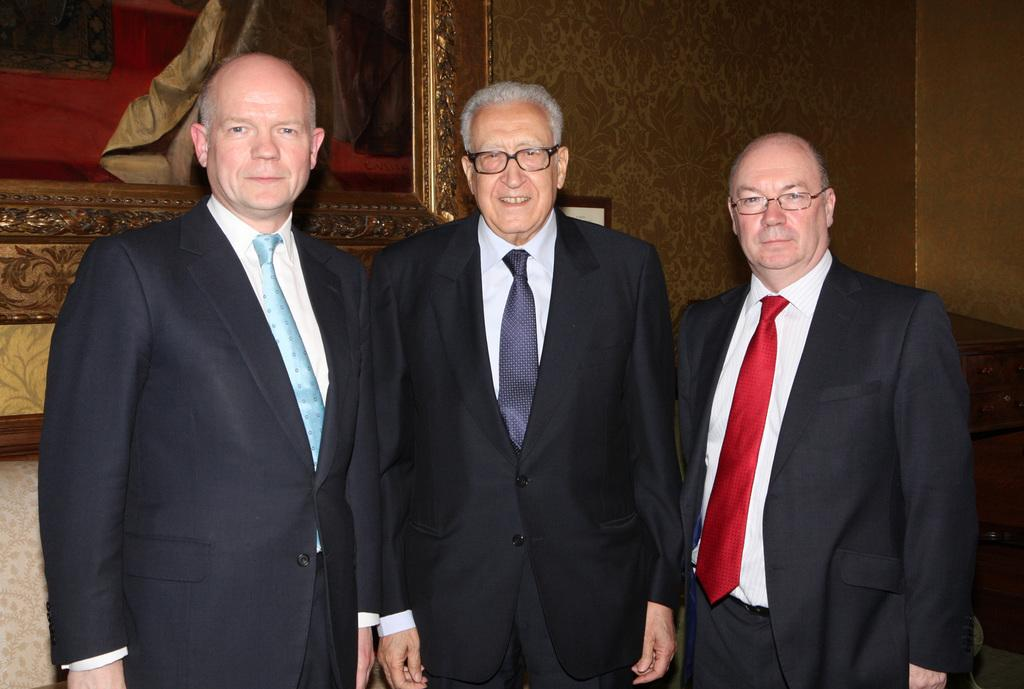What can be seen in the image? There are men standing in the image. Where are the men standing? The men are standing on the floor. What is visible in the background of the image? There is a wall hanging in the background of the image. What is the fly's desire in the image? There is no fly present in the image, so it is not possible to determine its desires. 